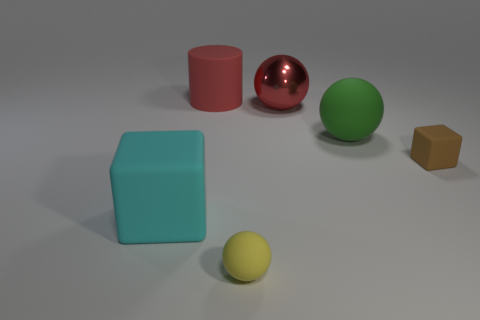Add 3 purple objects. How many objects exist? 9 Subtract all cylinders. How many objects are left? 5 Add 2 large shiny objects. How many large shiny objects exist? 3 Subtract 0 gray cylinders. How many objects are left? 6 Subtract all tiny cubes. Subtract all big red things. How many objects are left? 3 Add 5 red balls. How many red balls are left? 6 